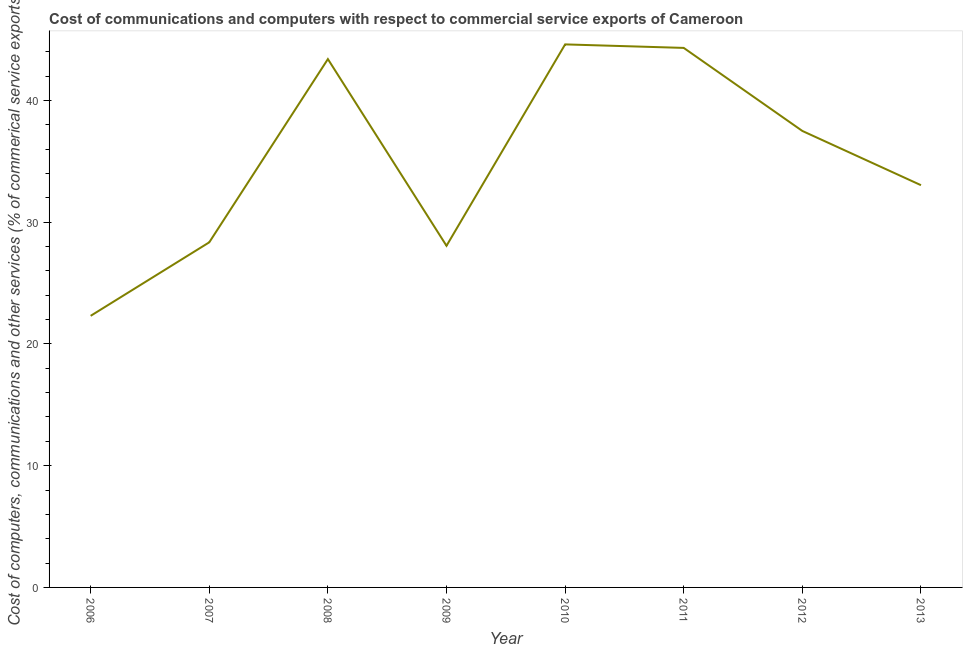What is the cost of communications in 2012?
Your response must be concise. 37.5. Across all years, what is the maximum cost of communications?
Keep it short and to the point. 44.61. Across all years, what is the minimum  computer and other services?
Your answer should be compact. 22.31. In which year was the  computer and other services maximum?
Provide a short and direct response. 2010. What is the sum of the cost of communications?
Provide a succinct answer. 281.59. What is the difference between the cost of communications in 2008 and 2012?
Provide a succinct answer. 5.9. What is the average  computer and other services per year?
Offer a terse response. 35.2. What is the median cost of communications?
Offer a very short reply. 35.27. In how many years, is the  computer and other services greater than 18 %?
Provide a succinct answer. 8. Do a majority of the years between 2007 and 2008 (inclusive) have cost of communications greater than 8 %?
Keep it short and to the point. Yes. What is the ratio of the  computer and other services in 2006 to that in 2013?
Offer a very short reply. 0.68. Is the difference between the  computer and other services in 2010 and 2011 greater than the difference between any two years?
Give a very brief answer. No. What is the difference between the highest and the second highest cost of communications?
Make the answer very short. 0.29. What is the difference between the highest and the lowest  computer and other services?
Provide a short and direct response. 22.3. How many lines are there?
Your answer should be compact. 1. What is the difference between two consecutive major ticks on the Y-axis?
Your answer should be very brief. 10. Does the graph contain grids?
Your answer should be compact. No. What is the title of the graph?
Provide a short and direct response. Cost of communications and computers with respect to commercial service exports of Cameroon. What is the label or title of the Y-axis?
Make the answer very short. Cost of computers, communications and other services (% of commerical service exports). What is the Cost of computers, communications and other services (% of commerical service exports) of 2006?
Provide a succinct answer. 22.31. What is the Cost of computers, communications and other services (% of commerical service exports) of 2007?
Ensure brevity in your answer.  28.35. What is the Cost of computers, communications and other services (% of commerical service exports) of 2008?
Make the answer very short. 43.4. What is the Cost of computers, communications and other services (% of commerical service exports) in 2009?
Offer a very short reply. 28.06. What is the Cost of computers, communications and other services (% of commerical service exports) of 2010?
Ensure brevity in your answer.  44.61. What is the Cost of computers, communications and other services (% of commerical service exports) in 2011?
Your response must be concise. 44.32. What is the Cost of computers, communications and other services (% of commerical service exports) in 2012?
Provide a succinct answer. 37.5. What is the Cost of computers, communications and other services (% of commerical service exports) of 2013?
Keep it short and to the point. 33.04. What is the difference between the Cost of computers, communications and other services (% of commerical service exports) in 2006 and 2007?
Your response must be concise. -6.04. What is the difference between the Cost of computers, communications and other services (% of commerical service exports) in 2006 and 2008?
Your answer should be very brief. -21.09. What is the difference between the Cost of computers, communications and other services (% of commerical service exports) in 2006 and 2009?
Offer a terse response. -5.75. What is the difference between the Cost of computers, communications and other services (% of commerical service exports) in 2006 and 2010?
Provide a succinct answer. -22.3. What is the difference between the Cost of computers, communications and other services (% of commerical service exports) in 2006 and 2011?
Make the answer very short. -22.01. What is the difference between the Cost of computers, communications and other services (% of commerical service exports) in 2006 and 2012?
Keep it short and to the point. -15.19. What is the difference between the Cost of computers, communications and other services (% of commerical service exports) in 2006 and 2013?
Ensure brevity in your answer.  -10.73. What is the difference between the Cost of computers, communications and other services (% of commerical service exports) in 2007 and 2008?
Make the answer very short. -15.05. What is the difference between the Cost of computers, communications and other services (% of commerical service exports) in 2007 and 2009?
Ensure brevity in your answer.  0.28. What is the difference between the Cost of computers, communications and other services (% of commerical service exports) in 2007 and 2010?
Offer a very short reply. -16.26. What is the difference between the Cost of computers, communications and other services (% of commerical service exports) in 2007 and 2011?
Ensure brevity in your answer.  -15.97. What is the difference between the Cost of computers, communications and other services (% of commerical service exports) in 2007 and 2012?
Ensure brevity in your answer.  -9.15. What is the difference between the Cost of computers, communications and other services (% of commerical service exports) in 2007 and 2013?
Keep it short and to the point. -4.69. What is the difference between the Cost of computers, communications and other services (% of commerical service exports) in 2008 and 2009?
Make the answer very short. 15.34. What is the difference between the Cost of computers, communications and other services (% of commerical service exports) in 2008 and 2010?
Make the answer very short. -1.21. What is the difference between the Cost of computers, communications and other services (% of commerical service exports) in 2008 and 2011?
Your answer should be very brief. -0.92. What is the difference between the Cost of computers, communications and other services (% of commerical service exports) in 2008 and 2012?
Your response must be concise. 5.9. What is the difference between the Cost of computers, communications and other services (% of commerical service exports) in 2008 and 2013?
Your response must be concise. 10.36. What is the difference between the Cost of computers, communications and other services (% of commerical service exports) in 2009 and 2010?
Ensure brevity in your answer.  -16.54. What is the difference between the Cost of computers, communications and other services (% of commerical service exports) in 2009 and 2011?
Provide a succinct answer. -16.25. What is the difference between the Cost of computers, communications and other services (% of commerical service exports) in 2009 and 2012?
Your response must be concise. -9.43. What is the difference between the Cost of computers, communications and other services (% of commerical service exports) in 2009 and 2013?
Provide a short and direct response. -4.98. What is the difference between the Cost of computers, communications and other services (% of commerical service exports) in 2010 and 2011?
Provide a short and direct response. 0.29. What is the difference between the Cost of computers, communications and other services (% of commerical service exports) in 2010 and 2012?
Offer a terse response. 7.11. What is the difference between the Cost of computers, communications and other services (% of commerical service exports) in 2010 and 2013?
Give a very brief answer. 11.57. What is the difference between the Cost of computers, communications and other services (% of commerical service exports) in 2011 and 2012?
Your answer should be very brief. 6.82. What is the difference between the Cost of computers, communications and other services (% of commerical service exports) in 2011 and 2013?
Offer a terse response. 11.28. What is the difference between the Cost of computers, communications and other services (% of commerical service exports) in 2012 and 2013?
Your answer should be very brief. 4.45. What is the ratio of the Cost of computers, communications and other services (% of commerical service exports) in 2006 to that in 2007?
Provide a succinct answer. 0.79. What is the ratio of the Cost of computers, communications and other services (% of commerical service exports) in 2006 to that in 2008?
Provide a succinct answer. 0.51. What is the ratio of the Cost of computers, communications and other services (% of commerical service exports) in 2006 to that in 2009?
Provide a succinct answer. 0.8. What is the ratio of the Cost of computers, communications and other services (% of commerical service exports) in 2006 to that in 2010?
Your response must be concise. 0.5. What is the ratio of the Cost of computers, communications and other services (% of commerical service exports) in 2006 to that in 2011?
Give a very brief answer. 0.5. What is the ratio of the Cost of computers, communications and other services (% of commerical service exports) in 2006 to that in 2012?
Your answer should be very brief. 0.59. What is the ratio of the Cost of computers, communications and other services (% of commerical service exports) in 2006 to that in 2013?
Provide a short and direct response. 0.68. What is the ratio of the Cost of computers, communications and other services (% of commerical service exports) in 2007 to that in 2008?
Your answer should be very brief. 0.65. What is the ratio of the Cost of computers, communications and other services (% of commerical service exports) in 2007 to that in 2009?
Your response must be concise. 1.01. What is the ratio of the Cost of computers, communications and other services (% of commerical service exports) in 2007 to that in 2010?
Offer a terse response. 0.64. What is the ratio of the Cost of computers, communications and other services (% of commerical service exports) in 2007 to that in 2011?
Provide a short and direct response. 0.64. What is the ratio of the Cost of computers, communications and other services (% of commerical service exports) in 2007 to that in 2012?
Give a very brief answer. 0.76. What is the ratio of the Cost of computers, communications and other services (% of commerical service exports) in 2007 to that in 2013?
Keep it short and to the point. 0.86. What is the ratio of the Cost of computers, communications and other services (% of commerical service exports) in 2008 to that in 2009?
Ensure brevity in your answer.  1.55. What is the ratio of the Cost of computers, communications and other services (% of commerical service exports) in 2008 to that in 2012?
Keep it short and to the point. 1.16. What is the ratio of the Cost of computers, communications and other services (% of commerical service exports) in 2008 to that in 2013?
Your answer should be very brief. 1.31. What is the ratio of the Cost of computers, communications and other services (% of commerical service exports) in 2009 to that in 2010?
Your response must be concise. 0.63. What is the ratio of the Cost of computers, communications and other services (% of commerical service exports) in 2009 to that in 2011?
Ensure brevity in your answer.  0.63. What is the ratio of the Cost of computers, communications and other services (% of commerical service exports) in 2009 to that in 2012?
Your response must be concise. 0.75. What is the ratio of the Cost of computers, communications and other services (% of commerical service exports) in 2009 to that in 2013?
Make the answer very short. 0.85. What is the ratio of the Cost of computers, communications and other services (% of commerical service exports) in 2010 to that in 2012?
Your answer should be compact. 1.19. What is the ratio of the Cost of computers, communications and other services (% of commerical service exports) in 2010 to that in 2013?
Offer a very short reply. 1.35. What is the ratio of the Cost of computers, communications and other services (% of commerical service exports) in 2011 to that in 2012?
Your answer should be very brief. 1.18. What is the ratio of the Cost of computers, communications and other services (% of commerical service exports) in 2011 to that in 2013?
Your answer should be very brief. 1.34. What is the ratio of the Cost of computers, communications and other services (% of commerical service exports) in 2012 to that in 2013?
Your answer should be compact. 1.14. 